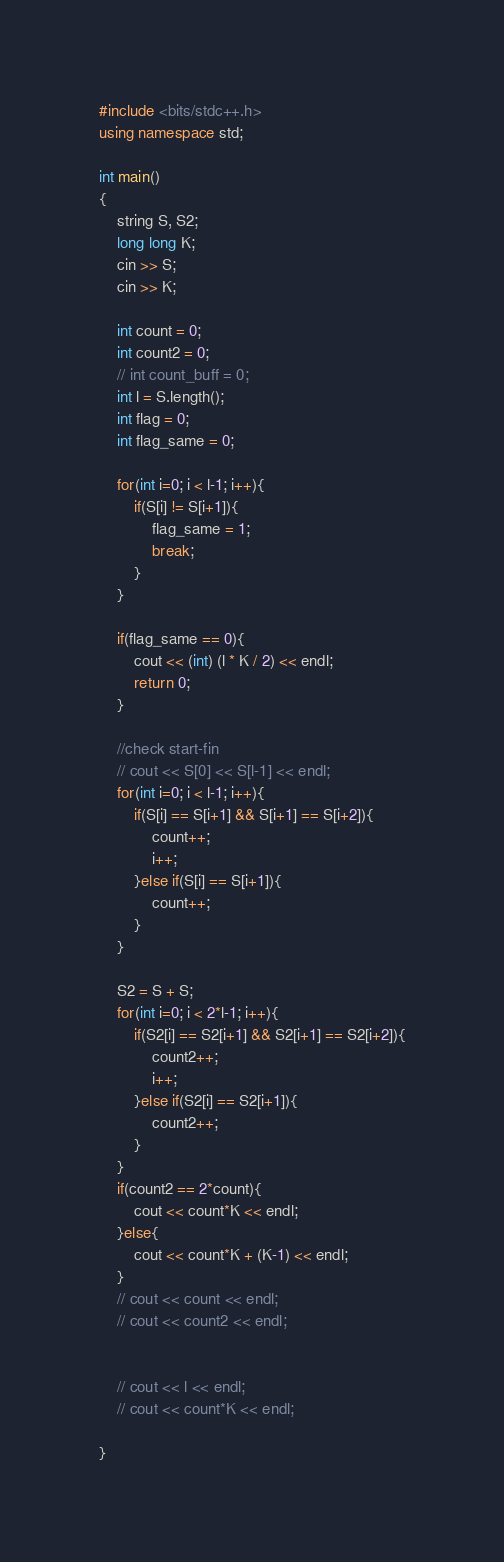<code> <loc_0><loc_0><loc_500><loc_500><_C++_>#include <bits/stdc++.h>
using namespace std;
 
int main()
{
    string S, S2;
    long long K; 
    cin >> S;
    cin >> K;
 
    int count = 0;
    int count2 = 0;
    // int count_buff = 0;
    int l = S.length();
    int flag = 0;
    int flag_same = 0;
 
    for(int i=0; i < l-1; i++){
        if(S[i] != S[i+1]){
            flag_same = 1;
            break;
        }
    }

    if(flag_same == 0){
        cout << (int) (l * K / 2) << endl;
        return 0; 
    }

    //check start-fin
    // cout << S[0] << S[l-1] << endl;
    for(int i=0; i < l-1; i++){
        if(S[i] == S[i+1] && S[i+1] == S[i+2]){
            count++;
            i++;
        }else if(S[i] == S[i+1]){
            count++;
        }
    }

    S2 = S + S;
    for(int i=0; i < 2*l-1; i++){
        if(S2[i] == S2[i+1] && S2[i+1] == S2[i+2]){
            count2++;
            i++;
        }else if(S2[i] == S2[i+1]){
            count2++;
        }
    }
    if(count2 == 2*count){
        cout << count*K << endl;
    }else{
        cout << count*K + (K-1) << endl;
    }
    // cout << count << endl;
    // cout << count2 << endl;
    
 
    // cout << l << endl;
    // cout << count*K << endl;
 
}</code> 